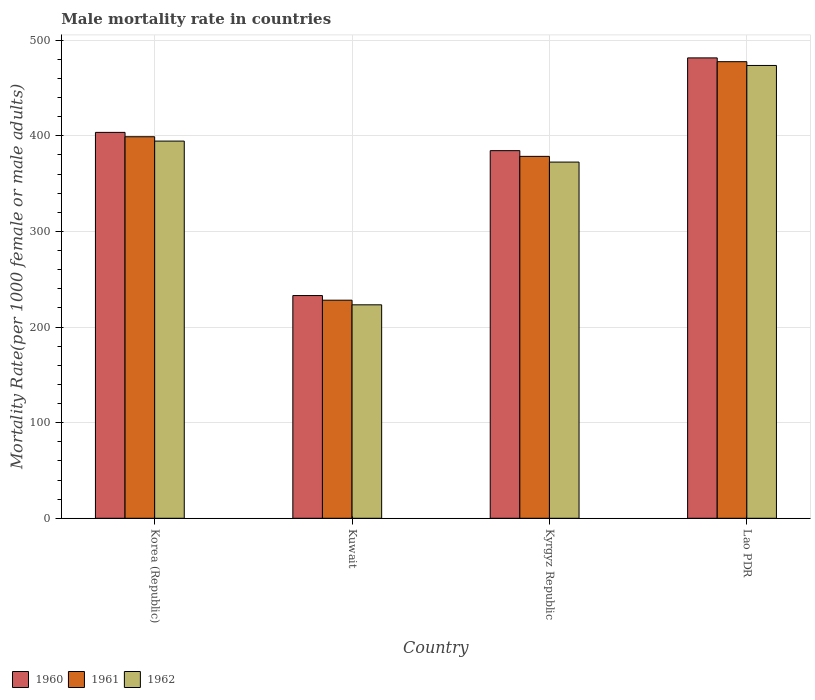Are the number of bars on each tick of the X-axis equal?
Offer a terse response. Yes. How many bars are there on the 1st tick from the left?
Give a very brief answer. 3. What is the label of the 3rd group of bars from the left?
Provide a short and direct response. Kyrgyz Republic. In how many cases, is the number of bars for a given country not equal to the number of legend labels?
Offer a very short reply. 0. What is the male mortality rate in 1961 in Korea (Republic)?
Ensure brevity in your answer.  399.02. Across all countries, what is the maximum male mortality rate in 1960?
Provide a succinct answer. 481.47. Across all countries, what is the minimum male mortality rate in 1960?
Give a very brief answer. 232.91. In which country was the male mortality rate in 1960 maximum?
Ensure brevity in your answer.  Lao PDR. In which country was the male mortality rate in 1962 minimum?
Keep it short and to the point. Kuwait. What is the total male mortality rate in 1962 in the graph?
Provide a short and direct response. 1463.74. What is the difference between the male mortality rate in 1961 in Korea (Republic) and that in Kyrgyz Republic?
Your answer should be compact. 20.53. What is the difference between the male mortality rate in 1960 in Kuwait and the male mortality rate in 1961 in Lao PDR?
Provide a short and direct response. -244.6. What is the average male mortality rate in 1960 per country?
Provide a succinct answer. 375.6. What is the difference between the male mortality rate of/in 1960 and male mortality rate of/in 1961 in Lao PDR?
Your answer should be very brief. 3.96. In how many countries, is the male mortality rate in 1961 greater than 40?
Keep it short and to the point. 4. What is the ratio of the male mortality rate in 1961 in Korea (Republic) to that in Kyrgyz Republic?
Your response must be concise. 1.05. Is the difference between the male mortality rate in 1960 in Kuwait and Kyrgyz Republic greater than the difference between the male mortality rate in 1961 in Kuwait and Kyrgyz Republic?
Offer a very short reply. No. What is the difference between the highest and the second highest male mortality rate in 1962?
Give a very brief answer. 79.09. What is the difference between the highest and the lowest male mortality rate in 1961?
Make the answer very short. 249.44. In how many countries, is the male mortality rate in 1960 greater than the average male mortality rate in 1960 taken over all countries?
Offer a very short reply. 3. Is it the case that in every country, the sum of the male mortality rate in 1960 and male mortality rate in 1961 is greater than the male mortality rate in 1962?
Offer a terse response. Yes. How many bars are there?
Ensure brevity in your answer.  12. Does the graph contain grids?
Your response must be concise. Yes. Where does the legend appear in the graph?
Keep it short and to the point. Bottom left. How are the legend labels stacked?
Your answer should be very brief. Horizontal. What is the title of the graph?
Your answer should be compact. Male mortality rate in countries. What is the label or title of the X-axis?
Your answer should be compact. Country. What is the label or title of the Y-axis?
Provide a succinct answer. Mortality Rate(per 1000 female or male adults). What is the Mortality Rate(per 1000 female or male adults) in 1960 in Korea (Republic)?
Give a very brief answer. 403.57. What is the Mortality Rate(per 1000 female or male adults) of 1961 in Korea (Republic)?
Your response must be concise. 399.02. What is the Mortality Rate(per 1000 female or male adults) in 1962 in Korea (Republic)?
Keep it short and to the point. 394.46. What is the Mortality Rate(per 1000 female or male adults) of 1960 in Kuwait?
Your response must be concise. 232.91. What is the Mortality Rate(per 1000 female or male adults) in 1961 in Kuwait?
Offer a very short reply. 228.07. What is the Mortality Rate(per 1000 female or male adults) in 1962 in Kuwait?
Offer a terse response. 223.23. What is the Mortality Rate(per 1000 female or male adults) in 1960 in Kyrgyz Republic?
Your response must be concise. 384.46. What is the Mortality Rate(per 1000 female or male adults) of 1961 in Kyrgyz Republic?
Offer a terse response. 378.48. What is the Mortality Rate(per 1000 female or male adults) in 1962 in Kyrgyz Republic?
Offer a very short reply. 372.5. What is the Mortality Rate(per 1000 female or male adults) in 1960 in Lao PDR?
Give a very brief answer. 481.47. What is the Mortality Rate(per 1000 female or male adults) in 1961 in Lao PDR?
Your answer should be very brief. 477.51. What is the Mortality Rate(per 1000 female or male adults) of 1962 in Lao PDR?
Your response must be concise. 473.55. Across all countries, what is the maximum Mortality Rate(per 1000 female or male adults) of 1960?
Your response must be concise. 481.47. Across all countries, what is the maximum Mortality Rate(per 1000 female or male adults) in 1961?
Your response must be concise. 477.51. Across all countries, what is the maximum Mortality Rate(per 1000 female or male adults) of 1962?
Give a very brief answer. 473.55. Across all countries, what is the minimum Mortality Rate(per 1000 female or male adults) in 1960?
Keep it short and to the point. 232.91. Across all countries, what is the minimum Mortality Rate(per 1000 female or male adults) of 1961?
Your answer should be compact. 228.07. Across all countries, what is the minimum Mortality Rate(per 1000 female or male adults) in 1962?
Your answer should be very brief. 223.23. What is the total Mortality Rate(per 1000 female or male adults) in 1960 in the graph?
Your answer should be compact. 1502.42. What is the total Mortality Rate(per 1000 female or male adults) in 1961 in the graph?
Your response must be concise. 1483.08. What is the total Mortality Rate(per 1000 female or male adults) of 1962 in the graph?
Your answer should be compact. 1463.74. What is the difference between the Mortality Rate(per 1000 female or male adults) in 1960 in Korea (Republic) and that in Kuwait?
Provide a succinct answer. 170.66. What is the difference between the Mortality Rate(per 1000 female or male adults) in 1961 in Korea (Republic) and that in Kuwait?
Your answer should be compact. 170.94. What is the difference between the Mortality Rate(per 1000 female or male adults) in 1962 in Korea (Republic) and that in Kuwait?
Provide a short and direct response. 171.23. What is the difference between the Mortality Rate(per 1000 female or male adults) in 1960 in Korea (Republic) and that in Kyrgyz Republic?
Make the answer very short. 19.11. What is the difference between the Mortality Rate(per 1000 female or male adults) in 1961 in Korea (Republic) and that in Kyrgyz Republic?
Your answer should be compact. 20.53. What is the difference between the Mortality Rate(per 1000 female or male adults) of 1962 in Korea (Republic) and that in Kyrgyz Republic?
Offer a terse response. 21.96. What is the difference between the Mortality Rate(per 1000 female or male adults) of 1960 in Korea (Republic) and that in Lao PDR?
Offer a terse response. -77.9. What is the difference between the Mortality Rate(per 1000 female or male adults) in 1961 in Korea (Republic) and that in Lao PDR?
Your response must be concise. -78.49. What is the difference between the Mortality Rate(per 1000 female or male adults) in 1962 in Korea (Republic) and that in Lao PDR?
Keep it short and to the point. -79.09. What is the difference between the Mortality Rate(per 1000 female or male adults) of 1960 in Kuwait and that in Kyrgyz Republic?
Your answer should be compact. -151.55. What is the difference between the Mortality Rate(per 1000 female or male adults) of 1961 in Kuwait and that in Kyrgyz Republic?
Provide a succinct answer. -150.41. What is the difference between the Mortality Rate(per 1000 female or male adults) in 1962 in Kuwait and that in Kyrgyz Republic?
Provide a succinct answer. -149.27. What is the difference between the Mortality Rate(per 1000 female or male adults) in 1960 in Kuwait and that in Lao PDR?
Give a very brief answer. -248.55. What is the difference between the Mortality Rate(per 1000 female or male adults) of 1961 in Kuwait and that in Lao PDR?
Your response must be concise. -249.44. What is the difference between the Mortality Rate(per 1000 female or male adults) in 1962 in Kuwait and that in Lao PDR?
Ensure brevity in your answer.  -250.32. What is the difference between the Mortality Rate(per 1000 female or male adults) in 1960 in Kyrgyz Republic and that in Lao PDR?
Keep it short and to the point. -97.01. What is the difference between the Mortality Rate(per 1000 female or male adults) in 1961 in Kyrgyz Republic and that in Lao PDR?
Provide a short and direct response. -99.03. What is the difference between the Mortality Rate(per 1000 female or male adults) of 1962 in Kyrgyz Republic and that in Lao PDR?
Offer a terse response. -101.05. What is the difference between the Mortality Rate(per 1000 female or male adults) in 1960 in Korea (Republic) and the Mortality Rate(per 1000 female or male adults) in 1961 in Kuwait?
Provide a short and direct response. 175.5. What is the difference between the Mortality Rate(per 1000 female or male adults) of 1960 in Korea (Republic) and the Mortality Rate(per 1000 female or male adults) of 1962 in Kuwait?
Your answer should be compact. 180.34. What is the difference between the Mortality Rate(per 1000 female or male adults) in 1961 in Korea (Republic) and the Mortality Rate(per 1000 female or male adults) in 1962 in Kuwait?
Give a very brief answer. 175.79. What is the difference between the Mortality Rate(per 1000 female or male adults) in 1960 in Korea (Republic) and the Mortality Rate(per 1000 female or male adults) in 1961 in Kyrgyz Republic?
Keep it short and to the point. 25.09. What is the difference between the Mortality Rate(per 1000 female or male adults) of 1960 in Korea (Republic) and the Mortality Rate(per 1000 female or male adults) of 1962 in Kyrgyz Republic?
Provide a succinct answer. 31.07. What is the difference between the Mortality Rate(per 1000 female or male adults) in 1961 in Korea (Republic) and the Mortality Rate(per 1000 female or male adults) in 1962 in Kyrgyz Republic?
Offer a very short reply. 26.52. What is the difference between the Mortality Rate(per 1000 female or male adults) of 1960 in Korea (Republic) and the Mortality Rate(per 1000 female or male adults) of 1961 in Lao PDR?
Your answer should be very brief. -73.94. What is the difference between the Mortality Rate(per 1000 female or male adults) of 1960 in Korea (Republic) and the Mortality Rate(per 1000 female or male adults) of 1962 in Lao PDR?
Your response must be concise. -69.98. What is the difference between the Mortality Rate(per 1000 female or male adults) in 1961 in Korea (Republic) and the Mortality Rate(per 1000 female or male adults) in 1962 in Lao PDR?
Provide a succinct answer. -74.53. What is the difference between the Mortality Rate(per 1000 female or male adults) of 1960 in Kuwait and the Mortality Rate(per 1000 female or male adults) of 1961 in Kyrgyz Republic?
Give a very brief answer. -145.57. What is the difference between the Mortality Rate(per 1000 female or male adults) in 1960 in Kuwait and the Mortality Rate(per 1000 female or male adults) in 1962 in Kyrgyz Republic?
Offer a very short reply. -139.59. What is the difference between the Mortality Rate(per 1000 female or male adults) in 1961 in Kuwait and the Mortality Rate(per 1000 female or male adults) in 1962 in Kyrgyz Republic?
Your answer should be compact. -144.43. What is the difference between the Mortality Rate(per 1000 female or male adults) of 1960 in Kuwait and the Mortality Rate(per 1000 female or male adults) of 1961 in Lao PDR?
Your answer should be very brief. -244.6. What is the difference between the Mortality Rate(per 1000 female or male adults) of 1960 in Kuwait and the Mortality Rate(per 1000 female or male adults) of 1962 in Lao PDR?
Give a very brief answer. -240.64. What is the difference between the Mortality Rate(per 1000 female or male adults) of 1961 in Kuwait and the Mortality Rate(per 1000 female or male adults) of 1962 in Lao PDR?
Give a very brief answer. -245.48. What is the difference between the Mortality Rate(per 1000 female or male adults) of 1960 in Kyrgyz Republic and the Mortality Rate(per 1000 female or male adults) of 1961 in Lao PDR?
Make the answer very short. -93.05. What is the difference between the Mortality Rate(per 1000 female or male adults) of 1960 in Kyrgyz Republic and the Mortality Rate(per 1000 female or male adults) of 1962 in Lao PDR?
Provide a short and direct response. -89.09. What is the difference between the Mortality Rate(per 1000 female or male adults) of 1961 in Kyrgyz Republic and the Mortality Rate(per 1000 female or male adults) of 1962 in Lao PDR?
Keep it short and to the point. -95.07. What is the average Mortality Rate(per 1000 female or male adults) of 1960 per country?
Offer a terse response. 375.6. What is the average Mortality Rate(per 1000 female or male adults) of 1961 per country?
Your response must be concise. 370.77. What is the average Mortality Rate(per 1000 female or male adults) of 1962 per country?
Offer a terse response. 365.93. What is the difference between the Mortality Rate(per 1000 female or male adults) in 1960 and Mortality Rate(per 1000 female or male adults) in 1961 in Korea (Republic)?
Provide a succinct answer. 4.56. What is the difference between the Mortality Rate(per 1000 female or male adults) of 1960 and Mortality Rate(per 1000 female or male adults) of 1962 in Korea (Republic)?
Give a very brief answer. 9.11. What is the difference between the Mortality Rate(per 1000 female or male adults) in 1961 and Mortality Rate(per 1000 female or male adults) in 1962 in Korea (Republic)?
Ensure brevity in your answer.  4.56. What is the difference between the Mortality Rate(per 1000 female or male adults) in 1960 and Mortality Rate(per 1000 female or male adults) in 1961 in Kuwait?
Provide a short and direct response. 4.84. What is the difference between the Mortality Rate(per 1000 female or male adults) of 1960 and Mortality Rate(per 1000 female or male adults) of 1962 in Kuwait?
Ensure brevity in your answer.  9.68. What is the difference between the Mortality Rate(per 1000 female or male adults) in 1961 and Mortality Rate(per 1000 female or male adults) in 1962 in Kuwait?
Give a very brief answer. 4.84. What is the difference between the Mortality Rate(per 1000 female or male adults) of 1960 and Mortality Rate(per 1000 female or male adults) of 1961 in Kyrgyz Republic?
Your answer should be compact. 5.98. What is the difference between the Mortality Rate(per 1000 female or male adults) of 1960 and Mortality Rate(per 1000 female or male adults) of 1962 in Kyrgyz Republic?
Offer a terse response. 11.96. What is the difference between the Mortality Rate(per 1000 female or male adults) in 1961 and Mortality Rate(per 1000 female or male adults) in 1962 in Kyrgyz Republic?
Offer a very short reply. 5.98. What is the difference between the Mortality Rate(per 1000 female or male adults) in 1960 and Mortality Rate(per 1000 female or male adults) in 1961 in Lao PDR?
Offer a very short reply. 3.96. What is the difference between the Mortality Rate(per 1000 female or male adults) of 1960 and Mortality Rate(per 1000 female or male adults) of 1962 in Lao PDR?
Make the answer very short. 7.92. What is the difference between the Mortality Rate(per 1000 female or male adults) of 1961 and Mortality Rate(per 1000 female or male adults) of 1962 in Lao PDR?
Ensure brevity in your answer.  3.96. What is the ratio of the Mortality Rate(per 1000 female or male adults) of 1960 in Korea (Republic) to that in Kuwait?
Your response must be concise. 1.73. What is the ratio of the Mortality Rate(per 1000 female or male adults) of 1961 in Korea (Republic) to that in Kuwait?
Ensure brevity in your answer.  1.75. What is the ratio of the Mortality Rate(per 1000 female or male adults) in 1962 in Korea (Republic) to that in Kuwait?
Offer a terse response. 1.77. What is the ratio of the Mortality Rate(per 1000 female or male adults) in 1960 in Korea (Republic) to that in Kyrgyz Republic?
Provide a succinct answer. 1.05. What is the ratio of the Mortality Rate(per 1000 female or male adults) of 1961 in Korea (Republic) to that in Kyrgyz Republic?
Provide a short and direct response. 1.05. What is the ratio of the Mortality Rate(per 1000 female or male adults) of 1962 in Korea (Republic) to that in Kyrgyz Republic?
Keep it short and to the point. 1.06. What is the ratio of the Mortality Rate(per 1000 female or male adults) of 1960 in Korea (Republic) to that in Lao PDR?
Your answer should be compact. 0.84. What is the ratio of the Mortality Rate(per 1000 female or male adults) in 1961 in Korea (Republic) to that in Lao PDR?
Make the answer very short. 0.84. What is the ratio of the Mortality Rate(per 1000 female or male adults) of 1962 in Korea (Republic) to that in Lao PDR?
Your response must be concise. 0.83. What is the ratio of the Mortality Rate(per 1000 female or male adults) in 1960 in Kuwait to that in Kyrgyz Republic?
Ensure brevity in your answer.  0.61. What is the ratio of the Mortality Rate(per 1000 female or male adults) in 1961 in Kuwait to that in Kyrgyz Republic?
Ensure brevity in your answer.  0.6. What is the ratio of the Mortality Rate(per 1000 female or male adults) of 1962 in Kuwait to that in Kyrgyz Republic?
Ensure brevity in your answer.  0.6. What is the ratio of the Mortality Rate(per 1000 female or male adults) in 1960 in Kuwait to that in Lao PDR?
Give a very brief answer. 0.48. What is the ratio of the Mortality Rate(per 1000 female or male adults) of 1961 in Kuwait to that in Lao PDR?
Ensure brevity in your answer.  0.48. What is the ratio of the Mortality Rate(per 1000 female or male adults) of 1962 in Kuwait to that in Lao PDR?
Provide a succinct answer. 0.47. What is the ratio of the Mortality Rate(per 1000 female or male adults) of 1960 in Kyrgyz Republic to that in Lao PDR?
Provide a succinct answer. 0.8. What is the ratio of the Mortality Rate(per 1000 female or male adults) in 1961 in Kyrgyz Republic to that in Lao PDR?
Provide a succinct answer. 0.79. What is the ratio of the Mortality Rate(per 1000 female or male adults) in 1962 in Kyrgyz Republic to that in Lao PDR?
Provide a succinct answer. 0.79. What is the difference between the highest and the second highest Mortality Rate(per 1000 female or male adults) in 1960?
Give a very brief answer. 77.9. What is the difference between the highest and the second highest Mortality Rate(per 1000 female or male adults) of 1961?
Provide a short and direct response. 78.49. What is the difference between the highest and the second highest Mortality Rate(per 1000 female or male adults) in 1962?
Provide a short and direct response. 79.09. What is the difference between the highest and the lowest Mortality Rate(per 1000 female or male adults) of 1960?
Your answer should be very brief. 248.55. What is the difference between the highest and the lowest Mortality Rate(per 1000 female or male adults) in 1961?
Give a very brief answer. 249.44. What is the difference between the highest and the lowest Mortality Rate(per 1000 female or male adults) in 1962?
Offer a terse response. 250.32. 